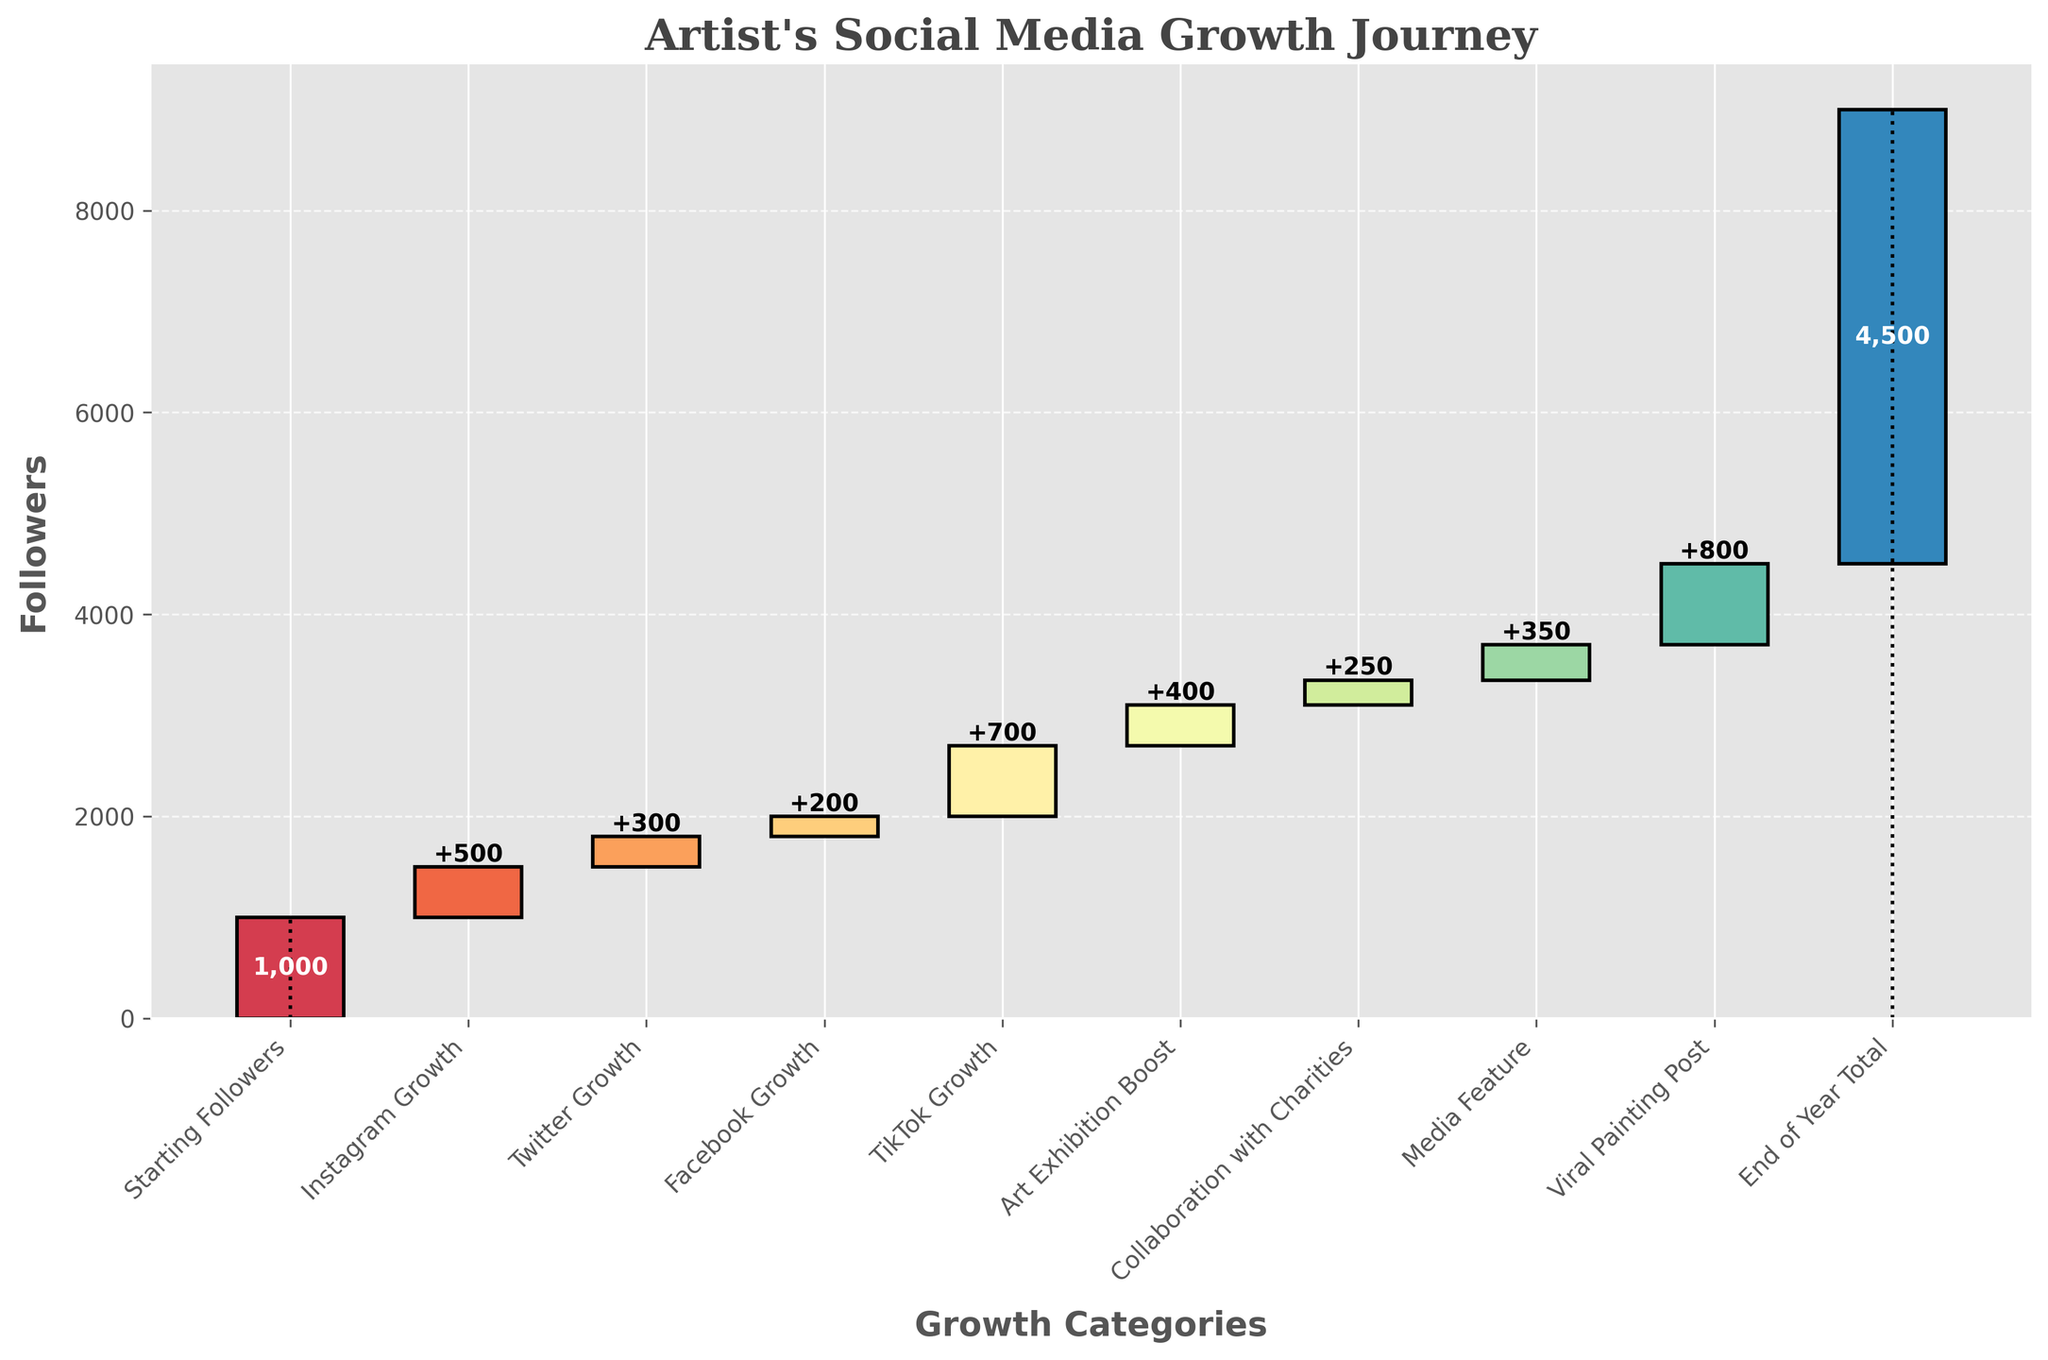What is the title of the plot? The title is displayed at the top of the plot in larger font. It should give a summary of the plot's content. In this case, it is called "Artist's Social Media Growth Journey".
Answer: Artist's Social Media Growth Journey How many categories are there in the waterfall chart? You can count the number of bars (segments) in the chart to determine the number of categories represented.
Answer: 9 Which category contributed the most to the artist's social media followers? By examining the height of the bars, the "Viral Painting Post" is the tallest, which means it contributed the most.
Answer: Viral Painting Post What was the total increase in followers from Instagram, Twitter, and Facebook combined? Add the individual values of Instagram Growth (500), Twitter Growth (300), and Facebook Growth (200): 500 + 300 + 200 = 1000.
Answer: 1000 Which categories contributed less than 300 followers each? Review each bar's value and identify "Twitter Growth" (300), "Facebook Growth" (200), and "Collaboration with Charities" (250) as categories contributing less than or equal to 300 followers.
Answer: Twitter Growth, Facebook Growth, Collaboration with Charities What is the total number of followers at the end of the year? The final cumulative endpoint is denoted as the "End of Year Total", giving the final count of followers. This value is directly given: 4500 followers.
Answer: 4500 What is the cumulative total after the "Media Feature" category? Cumulative sum of each category up to "Media Feature": 1000 (Starting) + 500 (Instagram) + 300 (Twitter) + 200 (Facebook) + 700 (TikTok) + 400 (Art Exhibition) + 250 (Collaboration) + 350 (Media Feature) = 3700.
Answer: 3700 How do the values compare between "Art Exhibition Boost" and "Collaboration with Charities"? Looking at the bar graph, "Art Exhibition Boost" has a value of 400, while "Collaboration with Charities" has a value of 250. Between these, "Art Exhibition Boost" contributes more.
Answer: Art Exhibition Boost > Collaboration with Charities Which category was the final addition before reaching the end-of-year total? The last bar before "End of Year Total" represents "Viral Painting Post".
Answer: Viral Painting Post What was the increase due to TikTok Growth along the timeline? The value adjacent to "TikTok Growth" indicates the increase for that category, which is shown as 700.
Answer: 700 